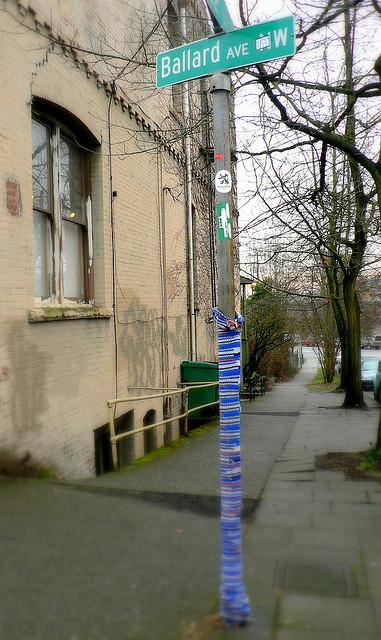What Street is this?
Be succinct. Ballard. What has happened to the signpost?
Give a very brief answer. Wrapped. Which direction are the signs pointing?
Short answer required. West. Is there a tripping hazard in the sidewalk area?
Concise answer only. Yes. 